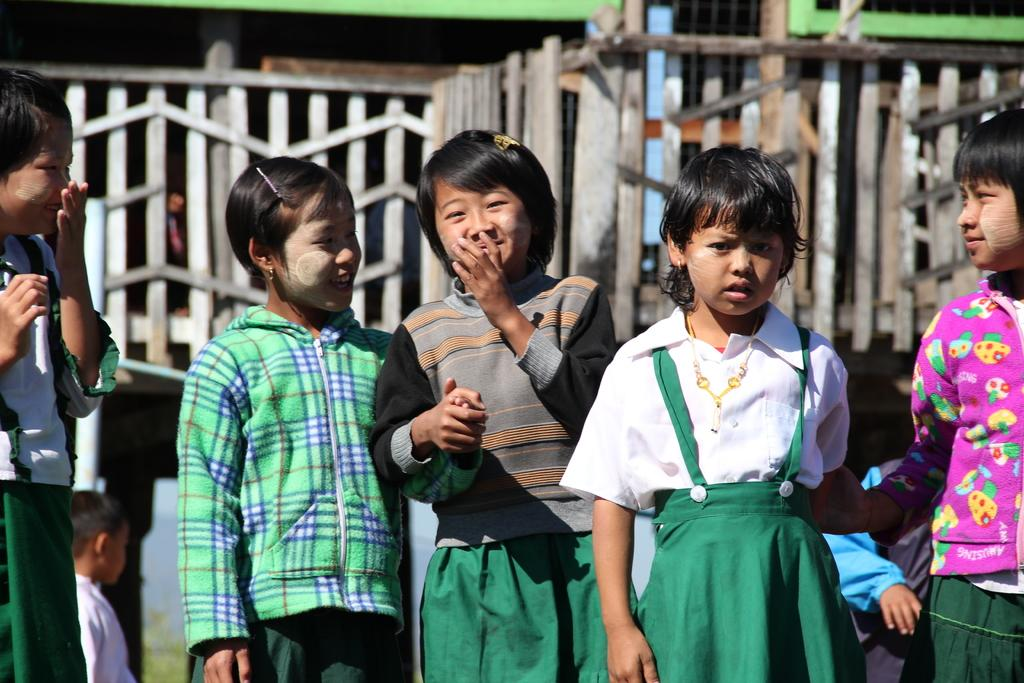Who is present in the image? There are children in the image. What are the children doing in the image? The children are standing and smiling. What can be seen in the background of the image? There is fencing visible in the image. What type of pig is visible in the image? There is no pig present in the image. What is the children using to eat their food in the image? The image does not show the children eating, so there is no spoon present. 